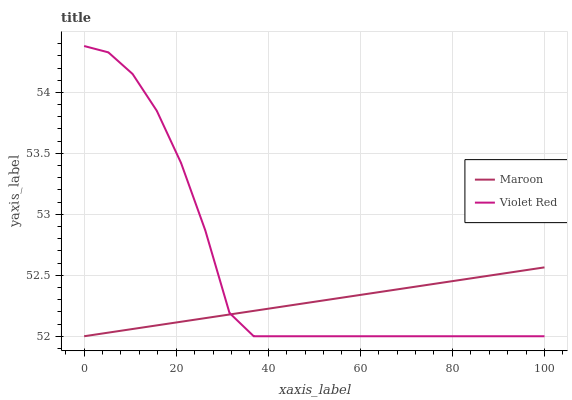Does Maroon have the minimum area under the curve?
Answer yes or no. Yes. Does Violet Red have the maximum area under the curve?
Answer yes or no. Yes. Does Maroon have the maximum area under the curve?
Answer yes or no. No. Is Maroon the smoothest?
Answer yes or no. Yes. Is Violet Red the roughest?
Answer yes or no. Yes. Is Maroon the roughest?
Answer yes or no. No. Does Maroon have the highest value?
Answer yes or no. No. 